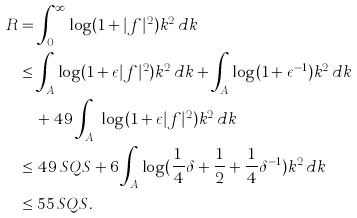Convert formula to latex. <formula><loc_0><loc_0><loc_500><loc_500>R & = \int _ { 0 } ^ { \infty } \log ( 1 + | f | ^ { 2 } ) k ^ { 2 } \, d k \\ & \leq \int _ { A } \log ( 1 + \epsilon | f | ^ { 2 } ) k ^ { 2 } \, d k + \int _ { A } \log ( 1 + \epsilon ^ { - 1 } ) k ^ { 2 } \, d k \\ & \quad + 4 9 \int _ { A ^ { c } } \log ( 1 + \epsilon | f | ^ { 2 } ) k ^ { 2 } \, d k \\ & \leq 4 9 \, S Q S + 6 \int _ { A } \log ( \frac { 1 } { 4 } \delta + \frac { 1 } { 2 } + \frac { 1 } { 4 } \delta ^ { - 1 } ) k ^ { 2 } \, d k \\ & \leq 5 5 \, S Q S .</formula> 